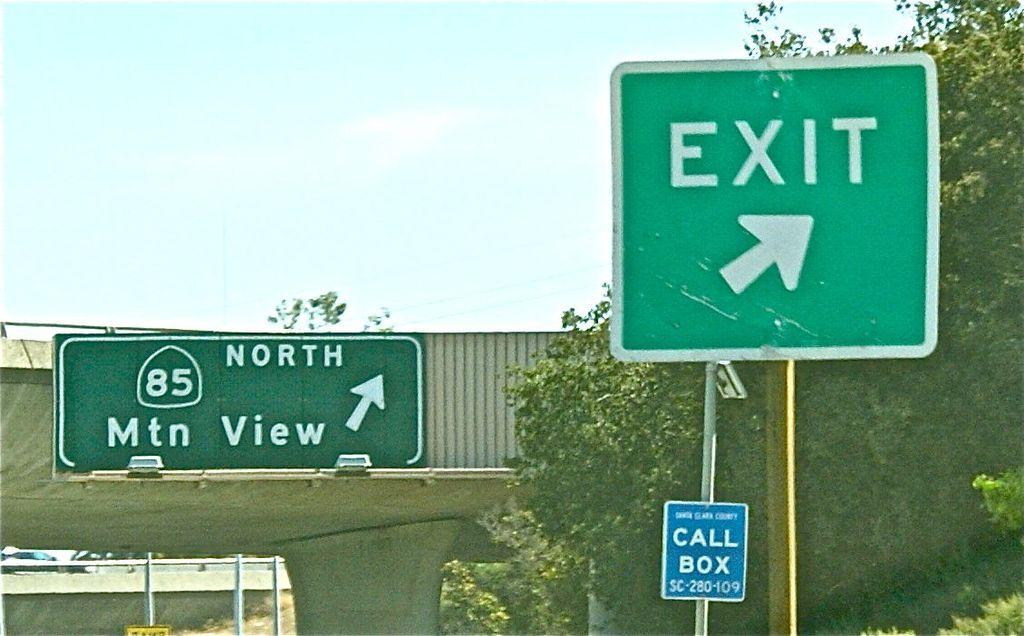<image>
Provide a brief description of the given image. Route 85 north leads to Mountain View according to the highway sign. 